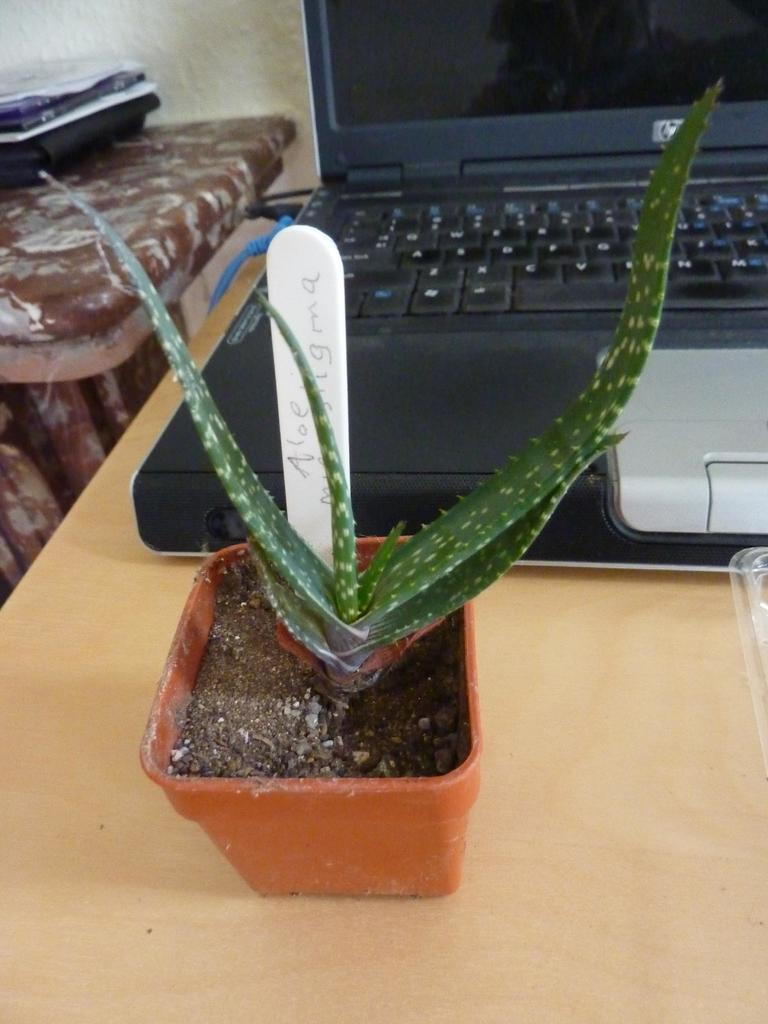What electronic device is visible in the image? There is a laptop in the image. What type of living organism is present in the image? There is a plant in a pot in the image. Where are the laptop and the plant located? Both the laptop and the plant are placed on a table. What else can be seen beside the laptop and the plant? There are some unspecified objects beside the laptop and the plant. Where is the toothbrush placed in the image? There is no toothbrush present in the image. What color is the orange beside the laptop? There is no orange present in the image. 